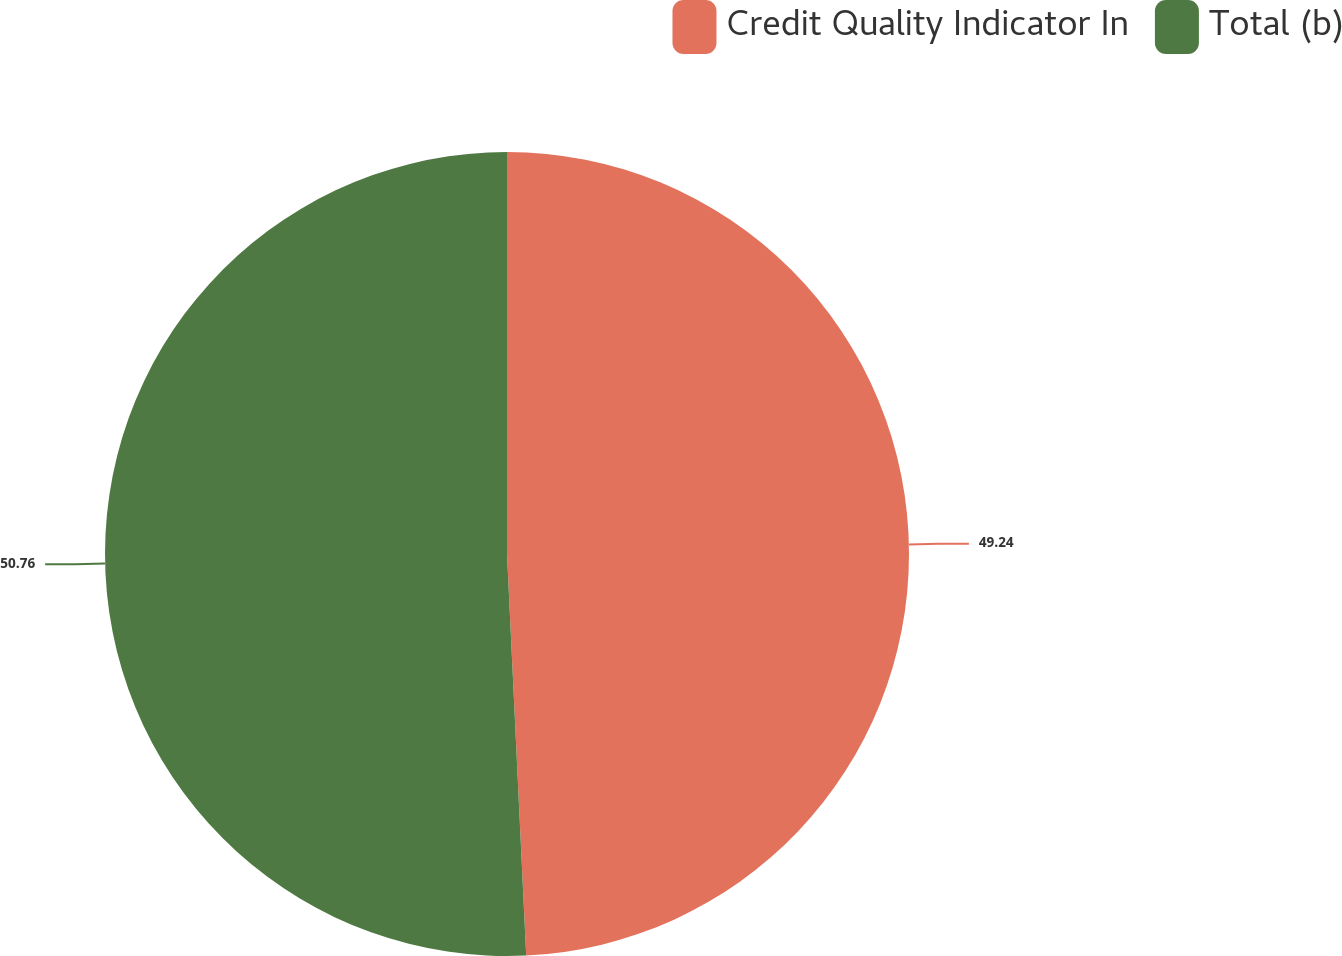<chart> <loc_0><loc_0><loc_500><loc_500><pie_chart><fcel>Credit Quality Indicator In<fcel>Total (b)<nl><fcel>49.24%<fcel>50.76%<nl></chart> 